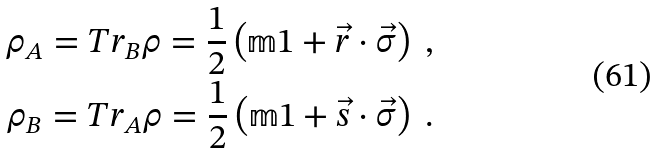Convert formula to latex. <formula><loc_0><loc_0><loc_500><loc_500>\rho _ { A } = T r _ { B } \rho = \frac { 1 } { 2 } \left ( \mathbb { m } { 1 } + \vec { r } \cdot \vec { \sigma } \right ) \ , \\ \rho _ { B } = T r _ { A } \rho = \frac { 1 } { 2 } \left ( \mathbb { m } { 1 } + \vec { s } \cdot \vec { \sigma } \right ) \ .</formula> 